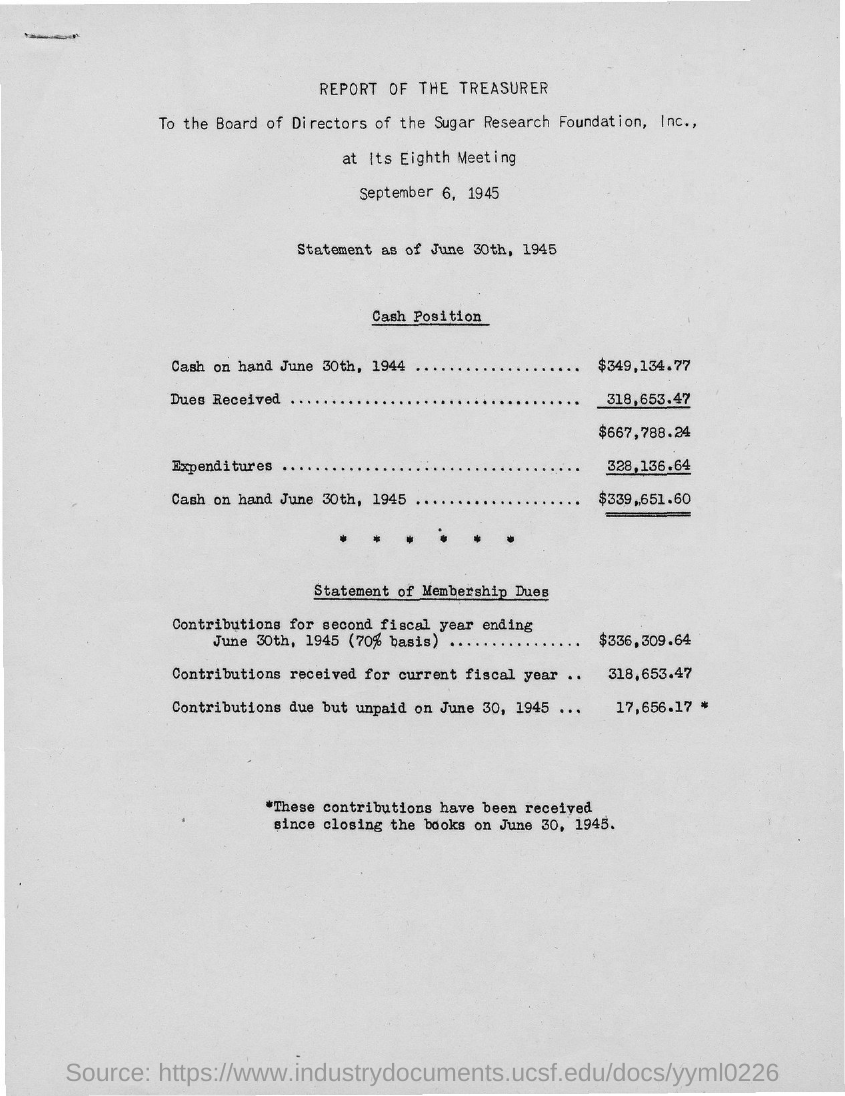What is the title of the document?
Give a very brief answer. REPORT OF THE TREASURER. 